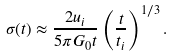Convert formula to latex. <formula><loc_0><loc_0><loc_500><loc_500>\sigma ( t ) \approx \frac { 2 u _ { i } } { 5 \pi G _ { 0 } t } \left ( \frac { t } { t _ { i } } \right ) ^ { 1 / 3 } .</formula> 